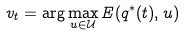Convert formula to latex. <formula><loc_0><loc_0><loc_500><loc_500>v _ { t } = \arg \max _ { u \in \mathcal { U } } E ( q ^ { * } ( t ) , u )</formula> 